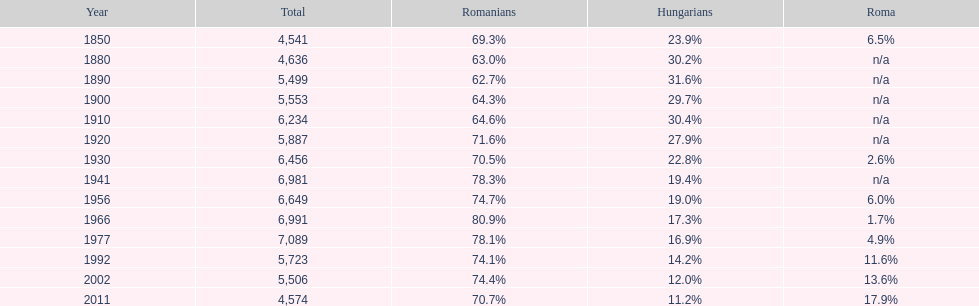What was the hungarian population in 1850? 23.9%. 